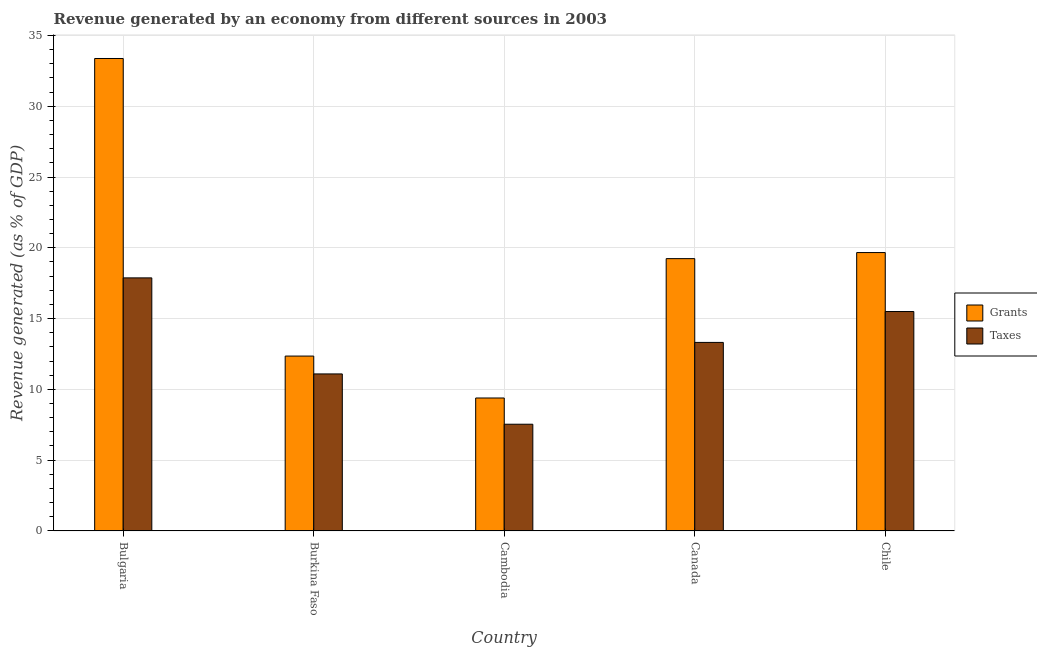How many different coloured bars are there?
Give a very brief answer. 2. How many bars are there on the 4th tick from the left?
Give a very brief answer. 2. What is the label of the 2nd group of bars from the left?
Provide a succinct answer. Burkina Faso. In how many cases, is the number of bars for a given country not equal to the number of legend labels?
Ensure brevity in your answer.  0. What is the revenue generated by taxes in Chile?
Your response must be concise. 15.5. Across all countries, what is the maximum revenue generated by taxes?
Your response must be concise. 17.88. Across all countries, what is the minimum revenue generated by grants?
Make the answer very short. 9.39. In which country was the revenue generated by taxes minimum?
Provide a short and direct response. Cambodia. What is the total revenue generated by grants in the graph?
Your response must be concise. 94.01. What is the difference between the revenue generated by taxes in Burkina Faso and that in Chile?
Keep it short and to the point. -4.41. What is the difference between the revenue generated by taxes in Cambodia and the revenue generated by grants in Canada?
Your answer should be very brief. -11.7. What is the average revenue generated by grants per country?
Ensure brevity in your answer.  18.8. What is the difference between the revenue generated by taxes and revenue generated by grants in Burkina Faso?
Ensure brevity in your answer.  -1.26. What is the ratio of the revenue generated by grants in Burkina Faso to that in Chile?
Offer a terse response. 0.63. What is the difference between the highest and the second highest revenue generated by taxes?
Give a very brief answer. 2.38. What is the difference between the highest and the lowest revenue generated by taxes?
Give a very brief answer. 10.34. In how many countries, is the revenue generated by taxes greater than the average revenue generated by taxes taken over all countries?
Provide a short and direct response. 3. What does the 2nd bar from the left in Canada represents?
Offer a very short reply. Taxes. What does the 2nd bar from the right in Chile represents?
Your answer should be very brief. Grants. How many bars are there?
Provide a succinct answer. 10. Are all the bars in the graph horizontal?
Offer a very short reply. No. What is the difference between two consecutive major ticks on the Y-axis?
Your answer should be compact. 5. Where does the legend appear in the graph?
Keep it short and to the point. Center right. What is the title of the graph?
Your answer should be compact. Revenue generated by an economy from different sources in 2003. Does "Fixed telephone" appear as one of the legend labels in the graph?
Make the answer very short. No. What is the label or title of the X-axis?
Provide a short and direct response. Country. What is the label or title of the Y-axis?
Your response must be concise. Revenue generated (as % of GDP). What is the Revenue generated (as % of GDP) in Grants in Bulgaria?
Keep it short and to the point. 33.37. What is the Revenue generated (as % of GDP) of Taxes in Bulgaria?
Offer a very short reply. 17.88. What is the Revenue generated (as % of GDP) in Grants in Burkina Faso?
Offer a terse response. 12.35. What is the Revenue generated (as % of GDP) in Taxes in Burkina Faso?
Give a very brief answer. 11.09. What is the Revenue generated (as % of GDP) of Grants in Cambodia?
Offer a very short reply. 9.39. What is the Revenue generated (as % of GDP) of Taxes in Cambodia?
Provide a succinct answer. 7.54. What is the Revenue generated (as % of GDP) of Grants in Canada?
Your response must be concise. 19.24. What is the Revenue generated (as % of GDP) in Taxes in Canada?
Your answer should be very brief. 13.32. What is the Revenue generated (as % of GDP) of Grants in Chile?
Keep it short and to the point. 19.66. What is the Revenue generated (as % of GDP) in Taxes in Chile?
Make the answer very short. 15.5. Across all countries, what is the maximum Revenue generated (as % of GDP) of Grants?
Provide a short and direct response. 33.37. Across all countries, what is the maximum Revenue generated (as % of GDP) of Taxes?
Your response must be concise. 17.88. Across all countries, what is the minimum Revenue generated (as % of GDP) in Grants?
Make the answer very short. 9.39. Across all countries, what is the minimum Revenue generated (as % of GDP) in Taxes?
Offer a terse response. 7.54. What is the total Revenue generated (as % of GDP) in Grants in the graph?
Keep it short and to the point. 94.01. What is the total Revenue generated (as % of GDP) of Taxes in the graph?
Your response must be concise. 65.32. What is the difference between the Revenue generated (as % of GDP) of Grants in Bulgaria and that in Burkina Faso?
Ensure brevity in your answer.  21.02. What is the difference between the Revenue generated (as % of GDP) of Taxes in Bulgaria and that in Burkina Faso?
Your response must be concise. 6.78. What is the difference between the Revenue generated (as % of GDP) in Grants in Bulgaria and that in Cambodia?
Make the answer very short. 23.98. What is the difference between the Revenue generated (as % of GDP) of Taxes in Bulgaria and that in Cambodia?
Your answer should be very brief. 10.34. What is the difference between the Revenue generated (as % of GDP) of Grants in Bulgaria and that in Canada?
Your answer should be compact. 14.14. What is the difference between the Revenue generated (as % of GDP) of Taxes in Bulgaria and that in Canada?
Keep it short and to the point. 4.56. What is the difference between the Revenue generated (as % of GDP) in Grants in Bulgaria and that in Chile?
Your answer should be very brief. 13.71. What is the difference between the Revenue generated (as % of GDP) of Taxes in Bulgaria and that in Chile?
Offer a very short reply. 2.38. What is the difference between the Revenue generated (as % of GDP) in Grants in Burkina Faso and that in Cambodia?
Offer a very short reply. 2.96. What is the difference between the Revenue generated (as % of GDP) of Taxes in Burkina Faso and that in Cambodia?
Offer a terse response. 3.55. What is the difference between the Revenue generated (as % of GDP) in Grants in Burkina Faso and that in Canada?
Keep it short and to the point. -6.88. What is the difference between the Revenue generated (as % of GDP) in Taxes in Burkina Faso and that in Canada?
Give a very brief answer. -2.23. What is the difference between the Revenue generated (as % of GDP) of Grants in Burkina Faso and that in Chile?
Provide a succinct answer. -7.31. What is the difference between the Revenue generated (as % of GDP) in Taxes in Burkina Faso and that in Chile?
Your answer should be compact. -4.41. What is the difference between the Revenue generated (as % of GDP) of Grants in Cambodia and that in Canada?
Offer a very short reply. -9.84. What is the difference between the Revenue generated (as % of GDP) of Taxes in Cambodia and that in Canada?
Keep it short and to the point. -5.78. What is the difference between the Revenue generated (as % of GDP) of Grants in Cambodia and that in Chile?
Your answer should be very brief. -10.27. What is the difference between the Revenue generated (as % of GDP) of Taxes in Cambodia and that in Chile?
Keep it short and to the point. -7.96. What is the difference between the Revenue generated (as % of GDP) in Grants in Canada and that in Chile?
Your response must be concise. -0.43. What is the difference between the Revenue generated (as % of GDP) of Taxes in Canada and that in Chile?
Your answer should be very brief. -2.18. What is the difference between the Revenue generated (as % of GDP) of Grants in Bulgaria and the Revenue generated (as % of GDP) of Taxes in Burkina Faso?
Make the answer very short. 22.28. What is the difference between the Revenue generated (as % of GDP) in Grants in Bulgaria and the Revenue generated (as % of GDP) in Taxes in Cambodia?
Keep it short and to the point. 25.83. What is the difference between the Revenue generated (as % of GDP) in Grants in Bulgaria and the Revenue generated (as % of GDP) in Taxes in Canada?
Keep it short and to the point. 20.05. What is the difference between the Revenue generated (as % of GDP) in Grants in Bulgaria and the Revenue generated (as % of GDP) in Taxes in Chile?
Provide a succinct answer. 17.87. What is the difference between the Revenue generated (as % of GDP) of Grants in Burkina Faso and the Revenue generated (as % of GDP) of Taxes in Cambodia?
Ensure brevity in your answer.  4.81. What is the difference between the Revenue generated (as % of GDP) of Grants in Burkina Faso and the Revenue generated (as % of GDP) of Taxes in Canada?
Offer a terse response. -0.97. What is the difference between the Revenue generated (as % of GDP) of Grants in Burkina Faso and the Revenue generated (as % of GDP) of Taxes in Chile?
Your answer should be compact. -3.15. What is the difference between the Revenue generated (as % of GDP) of Grants in Cambodia and the Revenue generated (as % of GDP) of Taxes in Canada?
Your answer should be compact. -3.93. What is the difference between the Revenue generated (as % of GDP) of Grants in Cambodia and the Revenue generated (as % of GDP) of Taxes in Chile?
Provide a succinct answer. -6.11. What is the difference between the Revenue generated (as % of GDP) of Grants in Canada and the Revenue generated (as % of GDP) of Taxes in Chile?
Your response must be concise. 3.74. What is the average Revenue generated (as % of GDP) of Grants per country?
Your response must be concise. 18.8. What is the average Revenue generated (as % of GDP) in Taxes per country?
Your answer should be very brief. 13.06. What is the difference between the Revenue generated (as % of GDP) in Grants and Revenue generated (as % of GDP) in Taxes in Bulgaria?
Your answer should be compact. 15.5. What is the difference between the Revenue generated (as % of GDP) of Grants and Revenue generated (as % of GDP) of Taxes in Burkina Faso?
Make the answer very short. 1.26. What is the difference between the Revenue generated (as % of GDP) of Grants and Revenue generated (as % of GDP) of Taxes in Cambodia?
Provide a short and direct response. 1.85. What is the difference between the Revenue generated (as % of GDP) of Grants and Revenue generated (as % of GDP) of Taxes in Canada?
Give a very brief answer. 5.92. What is the difference between the Revenue generated (as % of GDP) in Grants and Revenue generated (as % of GDP) in Taxes in Chile?
Give a very brief answer. 4.16. What is the ratio of the Revenue generated (as % of GDP) of Grants in Bulgaria to that in Burkina Faso?
Your answer should be very brief. 2.7. What is the ratio of the Revenue generated (as % of GDP) of Taxes in Bulgaria to that in Burkina Faso?
Your response must be concise. 1.61. What is the ratio of the Revenue generated (as % of GDP) of Grants in Bulgaria to that in Cambodia?
Your answer should be compact. 3.55. What is the ratio of the Revenue generated (as % of GDP) in Taxes in Bulgaria to that in Cambodia?
Your response must be concise. 2.37. What is the ratio of the Revenue generated (as % of GDP) in Grants in Bulgaria to that in Canada?
Give a very brief answer. 1.73. What is the ratio of the Revenue generated (as % of GDP) of Taxes in Bulgaria to that in Canada?
Your response must be concise. 1.34. What is the ratio of the Revenue generated (as % of GDP) in Grants in Bulgaria to that in Chile?
Provide a succinct answer. 1.7. What is the ratio of the Revenue generated (as % of GDP) in Taxes in Bulgaria to that in Chile?
Keep it short and to the point. 1.15. What is the ratio of the Revenue generated (as % of GDP) in Grants in Burkina Faso to that in Cambodia?
Your answer should be very brief. 1.32. What is the ratio of the Revenue generated (as % of GDP) in Taxes in Burkina Faso to that in Cambodia?
Offer a terse response. 1.47. What is the ratio of the Revenue generated (as % of GDP) in Grants in Burkina Faso to that in Canada?
Offer a very short reply. 0.64. What is the ratio of the Revenue generated (as % of GDP) in Taxes in Burkina Faso to that in Canada?
Ensure brevity in your answer.  0.83. What is the ratio of the Revenue generated (as % of GDP) of Grants in Burkina Faso to that in Chile?
Provide a succinct answer. 0.63. What is the ratio of the Revenue generated (as % of GDP) in Taxes in Burkina Faso to that in Chile?
Provide a short and direct response. 0.72. What is the ratio of the Revenue generated (as % of GDP) in Grants in Cambodia to that in Canada?
Give a very brief answer. 0.49. What is the ratio of the Revenue generated (as % of GDP) in Taxes in Cambodia to that in Canada?
Make the answer very short. 0.57. What is the ratio of the Revenue generated (as % of GDP) in Grants in Cambodia to that in Chile?
Make the answer very short. 0.48. What is the ratio of the Revenue generated (as % of GDP) of Taxes in Cambodia to that in Chile?
Offer a very short reply. 0.49. What is the ratio of the Revenue generated (as % of GDP) of Grants in Canada to that in Chile?
Keep it short and to the point. 0.98. What is the ratio of the Revenue generated (as % of GDP) in Taxes in Canada to that in Chile?
Keep it short and to the point. 0.86. What is the difference between the highest and the second highest Revenue generated (as % of GDP) of Grants?
Your response must be concise. 13.71. What is the difference between the highest and the second highest Revenue generated (as % of GDP) in Taxes?
Make the answer very short. 2.38. What is the difference between the highest and the lowest Revenue generated (as % of GDP) of Grants?
Ensure brevity in your answer.  23.98. What is the difference between the highest and the lowest Revenue generated (as % of GDP) of Taxes?
Your answer should be compact. 10.34. 